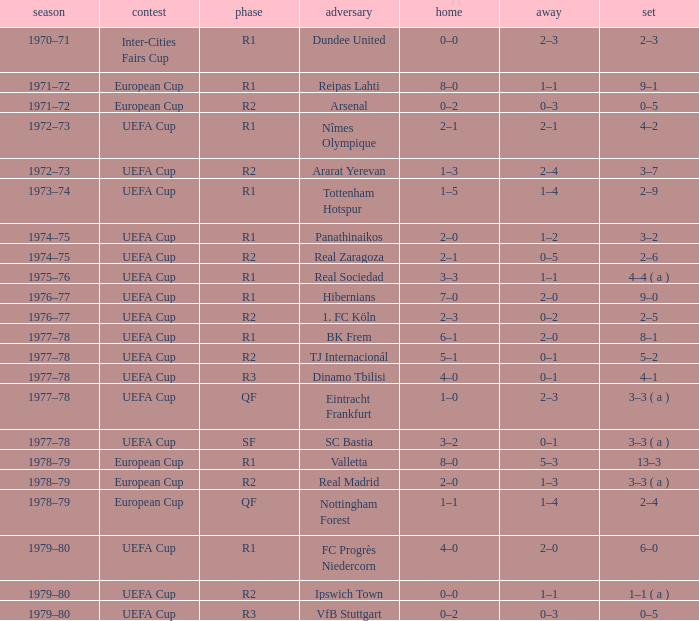Which Round has a Competition of uefa cup, and a Series of 5–2? R2. Could you parse the entire table as a dict? {'header': ['season', 'contest', 'phase', 'adversary', 'home', 'away', 'set'], 'rows': [['1970–71', 'Inter-Cities Fairs Cup', 'R1', 'Dundee United', '0–0', '2–3', '2–3'], ['1971–72', 'European Cup', 'R1', 'Reipas Lahti', '8–0', '1–1', '9–1'], ['1971–72', 'European Cup', 'R2', 'Arsenal', '0–2', '0–3', '0–5'], ['1972–73', 'UEFA Cup', 'R1', 'Nîmes Olympique', '2–1', '2–1', '4–2'], ['1972–73', 'UEFA Cup', 'R2', 'Ararat Yerevan', '1–3', '2–4', '3–7'], ['1973–74', 'UEFA Cup', 'R1', 'Tottenham Hotspur', '1–5', '1–4', '2–9'], ['1974–75', 'UEFA Cup', 'R1', 'Panathinaikos', '2–0', '1–2', '3–2'], ['1974–75', 'UEFA Cup', 'R2', 'Real Zaragoza', '2–1', '0–5', '2–6'], ['1975–76', 'UEFA Cup', 'R1', 'Real Sociedad', '3–3', '1–1', '4–4 ( a )'], ['1976–77', 'UEFA Cup', 'R1', 'Hibernians', '7–0', '2–0', '9–0'], ['1976–77', 'UEFA Cup', 'R2', '1. FC Köln', '2–3', '0–2', '2–5'], ['1977–78', 'UEFA Cup', 'R1', 'BK Frem', '6–1', '2–0', '8–1'], ['1977–78', 'UEFA Cup', 'R2', 'TJ Internacionál', '5–1', '0–1', '5–2'], ['1977–78', 'UEFA Cup', 'R3', 'Dinamo Tbilisi', '4–0', '0–1', '4–1'], ['1977–78', 'UEFA Cup', 'QF', 'Eintracht Frankfurt', '1–0', '2–3', '3–3 ( a )'], ['1977–78', 'UEFA Cup', 'SF', 'SC Bastia', '3–2', '0–1', '3–3 ( a )'], ['1978–79', 'European Cup', 'R1', 'Valletta', '8–0', '5–3', '13–3'], ['1978–79', 'European Cup', 'R2', 'Real Madrid', '2–0', '1–3', '3–3 ( a )'], ['1978–79', 'European Cup', 'QF', 'Nottingham Forest', '1–1', '1–4', '2–4'], ['1979–80', 'UEFA Cup', 'R1', 'FC Progrès Niedercorn', '4–0', '2–0', '6–0'], ['1979–80', 'UEFA Cup', 'R2', 'Ipswich Town', '0–0', '1–1', '1–1 ( a )'], ['1979–80', 'UEFA Cup', 'R3', 'VfB Stuttgart', '0–2', '0–3', '0–5']]} 